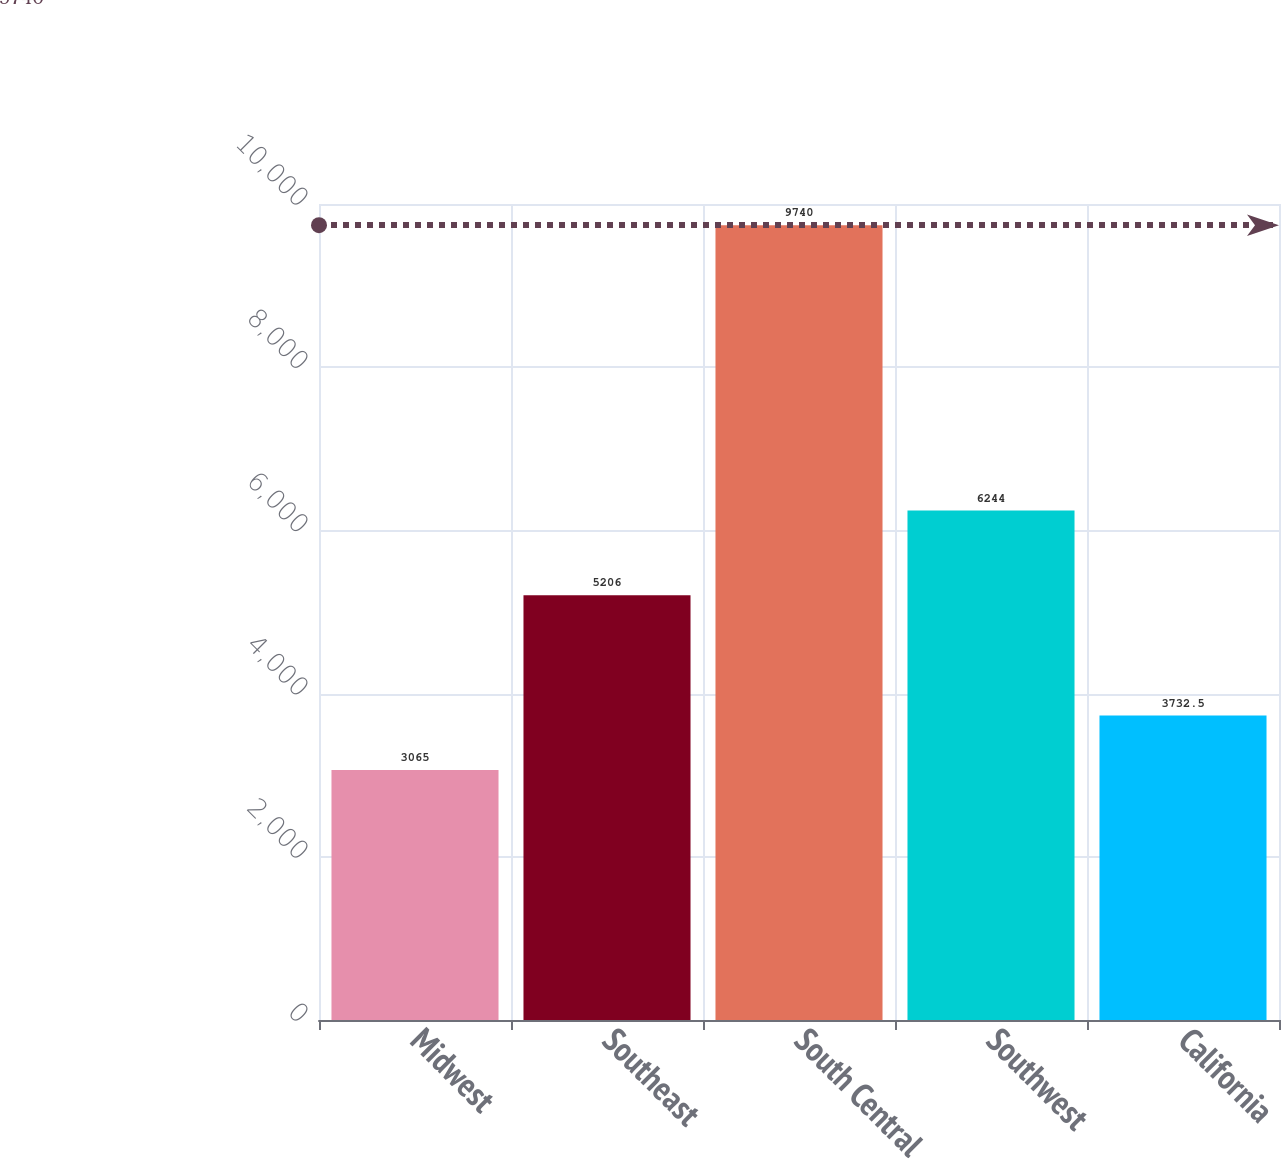Convert chart to OTSL. <chart><loc_0><loc_0><loc_500><loc_500><bar_chart><fcel>Midwest<fcel>Southeast<fcel>South Central<fcel>Southwest<fcel>California<nl><fcel>3065<fcel>5206<fcel>9740<fcel>6244<fcel>3732.5<nl></chart> 